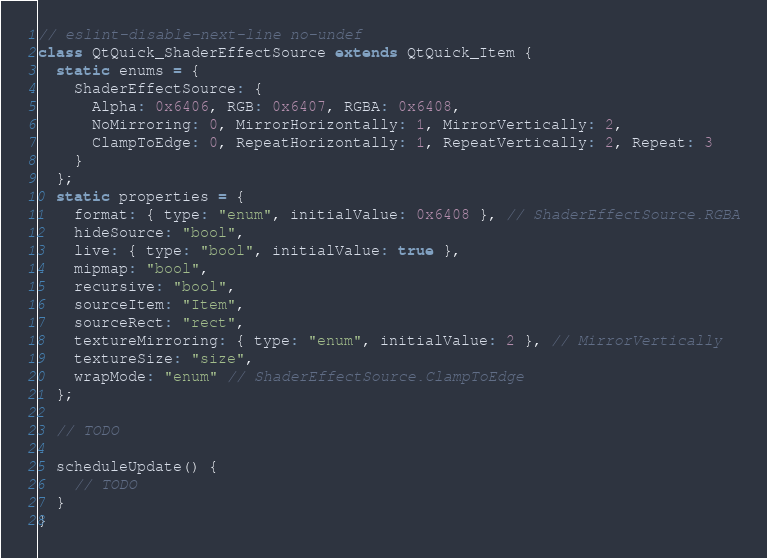Convert code to text. <code><loc_0><loc_0><loc_500><loc_500><_JavaScript_>// eslint-disable-next-line no-undef
class QtQuick_ShaderEffectSource extends QtQuick_Item {
  static enums = {
    ShaderEffectSource: {
      Alpha: 0x6406, RGB: 0x6407, RGBA: 0x6408,
      NoMirroring: 0, MirrorHorizontally: 1, MirrorVertically: 2,
      ClampToEdge: 0, RepeatHorizontally: 1, RepeatVertically: 2, Repeat: 3
    }
  };
  static properties = {
    format: { type: "enum", initialValue: 0x6408 }, // ShaderEffectSource.RGBA
    hideSource: "bool",
    live: { type: "bool", initialValue: true },
    mipmap: "bool",
    recursive: "bool",
    sourceItem: "Item",
    sourceRect: "rect",
    textureMirroring: { type: "enum", initialValue: 2 }, // MirrorVertically
    textureSize: "size",
    wrapMode: "enum" // ShaderEffectSource.ClampToEdge
  };

  // TODO

  scheduleUpdate() {
    // TODO
  }
}
</code> 